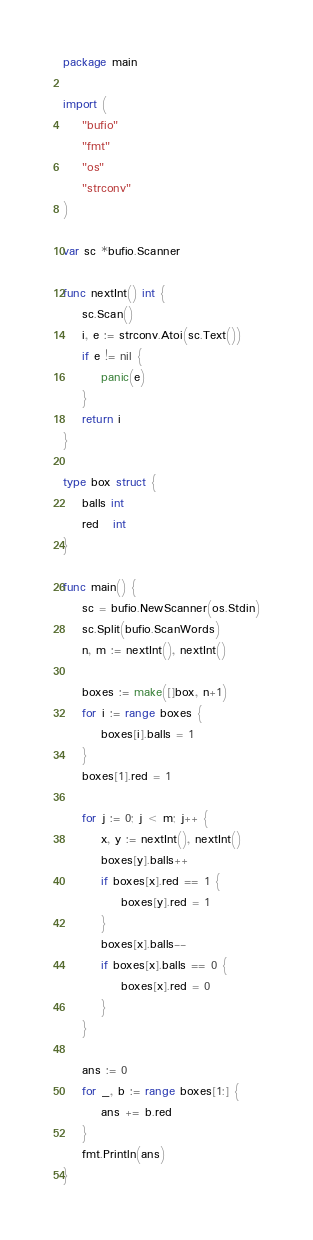<code> <loc_0><loc_0><loc_500><loc_500><_Go_>package main

import (
	"bufio"
	"fmt"
	"os"
	"strconv"
)

var sc *bufio.Scanner

func nextInt() int {
	sc.Scan()
	i, e := strconv.Atoi(sc.Text())
	if e != nil {
		panic(e)
	}
	return i
}

type box struct {
	balls int
	red   int
}

func main() {
	sc = bufio.NewScanner(os.Stdin)
	sc.Split(bufio.ScanWords)
	n, m := nextInt(), nextInt()

	boxes := make([]box, n+1)
	for i := range boxes {
		boxes[i].balls = 1
	}
	boxes[1].red = 1

	for j := 0; j < m; j++ {
		x, y := nextInt(), nextInt()
		boxes[y].balls++
		if boxes[x].red == 1 {
			boxes[y].red = 1
		}
		boxes[x].balls--
		if boxes[x].balls == 0 {
			boxes[x].red = 0
		}
	}

	ans := 0
	for _, b := range boxes[1:] {
		ans += b.red
	}
	fmt.Println(ans)
}
</code> 